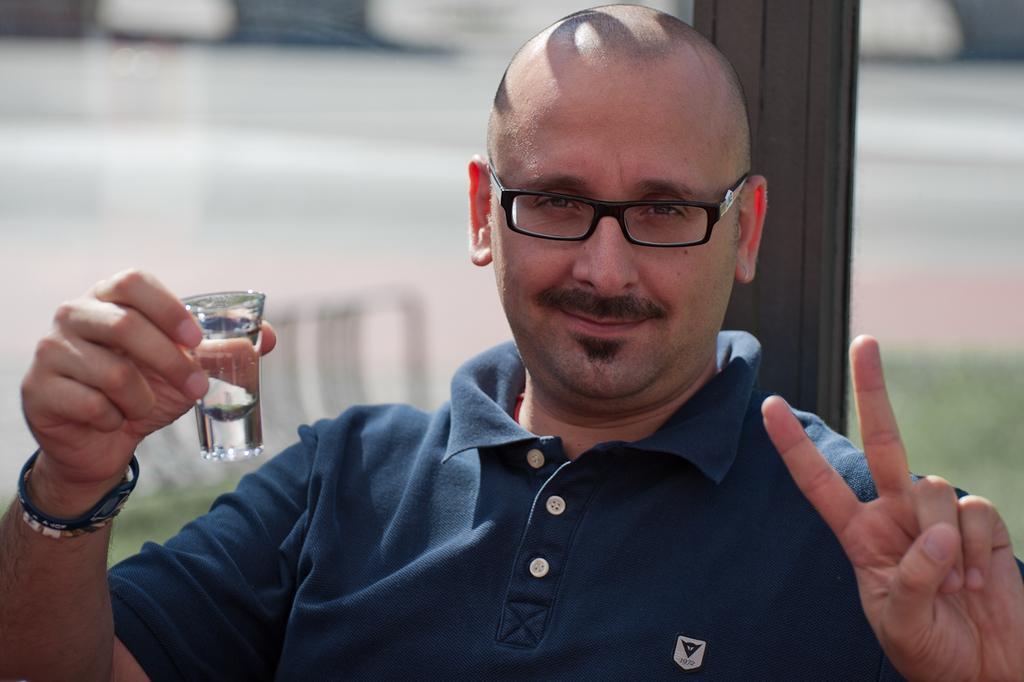Could you give a brief overview of what you see in this image? In the image there is a bald headed man in navy blue t-shirt holding a peg glass showing peace symbol standing in front of the pole, the background is blurry. 